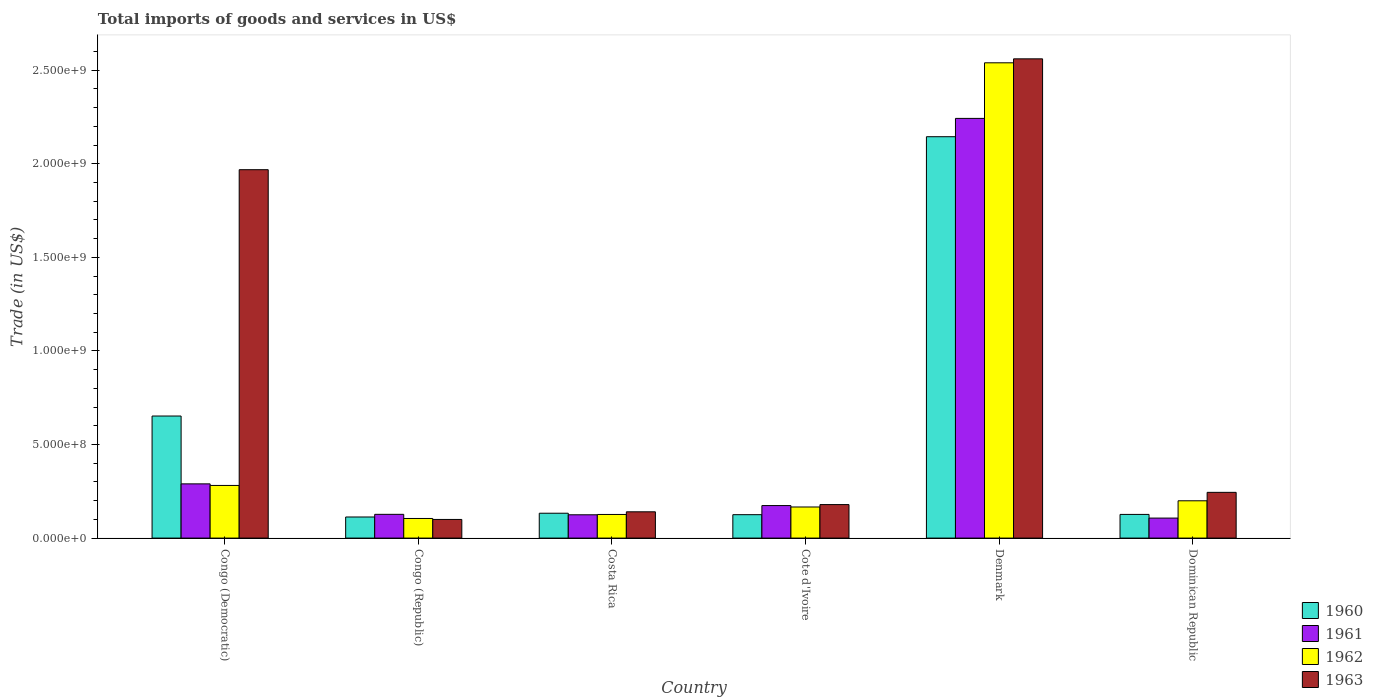Are the number of bars per tick equal to the number of legend labels?
Your answer should be very brief. Yes. Are the number of bars on each tick of the X-axis equal?
Provide a short and direct response. Yes. What is the label of the 2nd group of bars from the left?
Make the answer very short. Congo (Republic). What is the total imports of goods and services in 1963 in Dominican Republic?
Provide a succinct answer. 2.44e+08. Across all countries, what is the maximum total imports of goods and services in 1961?
Your answer should be very brief. 2.24e+09. Across all countries, what is the minimum total imports of goods and services in 1962?
Your answer should be very brief. 1.05e+08. In which country was the total imports of goods and services in 1961 maximum?
Offer a very short reply. Denmark. In which country was the total imports of goods and services in 1962 minimum?
Offer a terse response. Congo (Republic). What is the total total imports of goods and services in 1960 in the graph?
Your response must be concise. 3.29e+09. What is the difference between the total imports of goods and services in 1962 in Congo (Republic) and that in Cote d'Ivoire?
Your response must be concise. -6.13e+07. What is the difference between the total imports of goods and services in 1962 in Costa Rica and the total imports of goods and services in 1960 in Cote d'Ivoire?
Your response must be concise. 1.13e+06. What is the average total imports of goods and services in 1962 per country?
Give a very brief answer. 5.70e+08. What is the difference between the total imports of goods and services of/in 1962 and total imports of goods and services of/in 1961 in Congo (Republic)?
Offer a very short reply. -2.21e+07. In how many countries, is the total imports of goods and services in 1961 greater than 600000000 US$?
Ensure brevity in your answer.  1. What is the ratio of the total imports of goods and services in 1962 in Cote d'Ivoire to that in Denmark?
Your answer should be compact. 0.07. Is the total imports of goods and services in 1962 in Congo (Republic) less than that in Cote d'Ivoire?
Your answer should be very brief. Yes. What is the difference between the highest and the second highest total imports of goods and services in 1963?
Your answer should be compact. -1.72e+09. What is the difference between the highest and the lowest total imports of goods and services in 1960?
Give a very brief answer. 2.03e+09. In how many countries, is the total imports of goods and services in 1963 greater than the average total imports of goods and services in 1963 taken over all countries?
Your response must be concise. 2. Is it the case that in every country, the sum of the total imports of goods and services in 1960 and total imports of goods and services in 1961 is greater than the total imports of goods and services in 1962?
Your answer should be very brief. Yes. Are the values on the major ticks of Y-axis written in scientific E-notation?
Provide a short and direct response. Yes. Does the graph contain any zero values?
Keep it short and to the point. No. Where does the legend appear in the graph?
Give a very brief answer. Bottom right. How many legend labels are there?
Provide a short and direct response. 4. What is the title of the graph?
Provide a succinct answer. Total imports of goods and services in US$. Does "1969" appear as one of the legend labels in the graph?
Your response must be concise. No. What is the label or title of the Y-axis?
Give a very brief answer. Trade (in US$). What is the Trade (in US$) of 1960 in Congo (Democratic)?
Keep it short and to the point. 6.52e+08. What is the Trade (in US$) in 1961 in Congo (Democratic)?
Ensure brevity in your answer.  2.90e+08. What is the Trade (in US$) in 1962 in Congo (Democratic)?
Your answer should be compact. 2.81e+08. What is the Trade (in US$) in 1963 in Congo (Democratic)?
Offer a very short reply. 1.97e+09. What is the Trade (in US$) in 1960 in Congo (Republic)?
Make the answer very short. 1.13e+08. What is the Trade (in US$) in 1961 in Congo (Republic)?
Keep it short and to the point. 1.27e+08. What is the Trade (in US$) in 1962 in Congo (Republic)?
Provide a short and direct response. 1.05e+08. What is the Trade (in US$) in 1963 in Congo (Republic)?
Your answer should be very brief. 9.96e+07. What is the Trade (in US$) in 1960 in Costa Rica?
Make the answer very short. 1.33e+08. What is the Trade (in US$) of 1961 in Costa Rica?
Offer a terse response. 1.25e+08. What is the Trade (in US$) in 1962 in Costa Rica?
Your answer should be compact. 1.26e+08. What is the Trade (in US$) in 1963 in Costa Rica?
Your response must be concise. 1.40e+08. What is the Trade (in US$) of 1960 in Cote d'Ivoire?
Your answer should be very brief. 1.25e+08. What is the Trade (in US$) in 1961 in Cote d'Ivoire?
Offer a very short reply. 1.74e+08. What is the Trade (in US$) in 1962 in Cote d'Ivoire?
Your response must be concise. 1.66e+08. What is the Trade (in US$) of 1963 in Cote d'Ivoire?
Keep it short and to the point. 1.79e+08. What is the Trade (in US$) of 1960 in Denmark?
Provide a succinct answer. 2.14e+09. What is the Trade (in US$) in 1961 in Denmark?
Your answer should be very brief. 2.24e+09. What is the Trade (in US$) of 1962 in Denmark?
Keep it short and to the point. 2.54e+09. What is the Trade (in US$) of 1963 in Denmark?
Your answer should be very brief. 2.56e+09. What is the Trade (in US$) in 1960 in Dominican Republic?
Your answer should be very brief. 1.26e+08. What is the Trade (in US$) in 1961 in Dominican Republic?
Provide a short and direct response. 1.07e+08. What is the Trade (in US$) in 1962 in Dominican Republic?
Your answer should be very brief. 1.99e+08. What is the Trade (in US$) in 1963 in Dominican Republic?
Your answer should be compact. 2.44e+08. Across all countries, what is the maximum Trade (in US$) of 1960?
Your answer should be compact. 2.14e+09. Across all countries, what is the maximum Trade (in US$) of 1961?
Keep it short and to the point. 2.24e+09. Across all countries, what is the maximum Trade (in US$) of 1962?
Your response must be concise. 2.54e+09. Across all countries, what is the maximum Trade (in US$) in 1963?
Provide a succinct answer. 2.56e+09. Across all countries, what is the minimum Trade (in US$) of 1960?
Ensure brevity in your answer.  1.13e+08. Across all countries, what is the minimum Trade (in US$) of 1961?
Your answer should be compact. 1.07e+08. Across all countries, what is the minimum Trade (in US$) of 1962?
Make the answer very short. 1.05e+08. Across all countries, what is the minimum Trade (in US$) in 1963?
Offer a terse response. 9.96e+07. What is the total Trade (in US$) in 1960 in the graph?
Ensure brevity in your answer.  3.29e+09. What is the total Trade (in US$) in 1961 in the graph?
Provide a succinct answer. 3.06e+09. What is the total Trade (in US$) of 1962 in the graph?
Ensure brevity in your answer.  3.42e+09. What is the total Trade (in US$) of 1963 in the graph?
Make the answer very short. 5.19e+09. What is the difference between the Trade (in US$) in 1960 in Congo (Democratic) and that in Congo (Republic)?
Ensure brevity in your answer.  5.40e+08. What is the difference between the Trade (in US$) of 1961 in Congo (Democratic) and that in Congo (Republic)?
Give a very brief answer. 1.63e+08. What is the difference between the Trade (in US$) in 1962 in Congo (Democratic) and that in Congo (Republic)?
Keep it short and to the point. 1.76e+08. What is the difference between the Trade (in US$) in 1963 in Congo (Democratic) and that in Congo (Republic)?
Offer a terse response. 1.87e+09. What is the difference between the Trade (in US$) of 1960 in Congo (Democratic) and that in Costa Rica?
Offer a terse response. 5.19e+08. What is the difference between the Trade (in US$) in 1961 in Congo (Democratic) and that in Costa Rica?
Keep it short and to the point. 1.65e+08. What is the difference between the Trade (in US$) of 1962 in Congo (Democratic) and that in Costa Rica?
Give a very brief answer. 1.55e+08. What is the difference between the Trade (in US$) in 1963 in Congo (Democratic) and that in Costa Rica?
Your answer should be compact. 1.83e+09. What is the difference between the Trade (in US$) of 1960 in Congo (Democratic) and that in Cote d'Ivoire?
Keep it short and to the point. 5.27e+08. What is the difference between the Trade (in US$) in 1961 in Congo (Democratic) and that in Cote d'Ivoire?
Give a very brief answer. 1.16e+08. What is the difference between the Trade (in US$) of 1962 in Congo (Democratic) and that in Cote d'Ivoire?
Keep it short and to the point. 1.15e+08. What is the difference between the Trade (in US$) in 1963 in Congo (Democratic) and that in Cote d'Ivoire?
Keep it short and to the point. 1.79e+09. What is the difference between the Trade (in US$) of 1960 in Congo (Democratic) and that in Denmark?
Offer a very short reply. -1.49e+09. What is the difference between the Trade (in US$) of 1961 in Congo (Democratic) and that in Denmark?
Make the answer very short. -1.95e+09. What is the difference between the Trade (in US$) in 1962 in Congo (Democratic) and that in Denmark?
Make the answer very short. -2.26e+09. What is the difference between the Trade (in US$) of 1963 in Congo (Democratic) and that in Denmark?
Your answer should be very brief. -5.92e+08. What is the difference between the Trade (in US$) of 1960 in Congo (Democratic) and that in Dominican Republic?
Ensure brevity in your answer.  5.26e+08. What is the difference between the Trade (in US$) of 1961 in Congo (Democratic) and that in Dominican Republic?
Give a very brief answer. 1.83e+08. What is the difference between the Trade (in US$) of 1962 in Congo (Democratic) and that in Dominican Republic?
Give a very brief answer. 8.20e+07. What is the difference between the Trade (in US$) of 1963 in Congo (Democratic) and that in Dominican Republic?
Keep it short and to the point. 1.72e+09. What is the difference between the Trade (in US$) of 1960 in Congo (Republic) and that in Costa Rica?
Provide a short and direct response. -2.01e+07. What is the difference between the Trade (in US$) of 1961 in Congo (Republic) and that in Costa Rica?
Provide a succinct answer. 2.36e+06. What is the difference between the Trade (in US$) of 1962 in Congo (Republic) and that in Costa Rica?
Keep it short and to the point. -2.14e+07. What is the difference between the Trade (in US$) of 1963 in Congo (Republic) and that in Costa Rica?
Provide a succinct answer. -4.08e+07. What is the difference between the Trade (in US$) in 1960 in Congo (Republic) and that in Cote d'Ivoire?
Provide a succinct answer. -1.23e+07. What is the difference between the Trade (in US$) of 1961 in Congo (Republic) and that in Cote d'Ivoire?
Offer a terse response. -4.69e+07. What is the difference between the Trade (in US$) of 1962 in Congo (Republic) and that in Cote d'Ivoire?
Give a very brief answer. -6.13e+07. What is the difference between the Trade (in US$) in 1963 in Congo (Republic) and that in Cote d'Ivoire?
Offer a terse response. -7.94e+07. What is the difference between the Trade (in US$) in 1960 in Congo (Republic) and that in Denmark?
Your answer should be very brief. -2.03e+09. What is the difference between the Trade (in US$) in 1961 in Congo (Republic) and that in Denmark?
Your answer should be very brief. -2.12e+09. What is the difference between the Trade (in US$) in 1962 in Congo (Republic) and that in Denmark?
Your answer should be compact. -2.43e+09. What is the difference between the Trade (in US$) of 1963 in Congo (Republic) and that in Denmark?
Your response must be concise. -2.46e+09. What is the difference between the Trade (in US$) in 1960 in Congo (Republic) and that in Dominican Republic?
Your answer should be very brief. -1.37e+07. What is the difference between the Trade (in US$) in 1961 in Congo (Republic) and that in Dominican Republic?
Provide a short and direct response. 2.00e+07. What is the difference between the Trade (in US$) of 1962 in Congo (Republic) and that in Dominican Republic?
Provide a succinct answer. -9.45e+07. What is the difference between the Trade (in US$) in 1963 in Congo (Republic) and that in Dominican Republic?
Keep it short and to the point. -1.45e+08. What is the difference between the Trade (in US$) in 1960 in Costa Rica and that in Cote d'Ivoire?
Your answer should be very brief. 7.75e+06. What is the difference between the Trade (in US$) in 1961 in Costa Rica and that in Cote d'Ivoire?
Give a very brief answer. -4.92e+07. What is the difference between the Trade (in US$) of 1962 in Costa Rica and that in Cote d'Ivoire?
Provide a short and direct response. -3.99e+07. What is the difference between the Trade (in US$) in 1963 in Costa Rica and that in Cote d'Ivoire?
Provide a short and direct response. -3.86e+07. What is the difference between the Trade (in US$) in 1960 in Costa Rica and that in Denmark?
Your response must be concise. -2.01e+09. What is the difference between the Trade (in US$) in 1961 in Costa Rica and that in Denmark?
Your answer should be compact. -2.12e+09. What is the difference between the Trade (in US$) of 1962 in Costa Rica and that in Denmark?
Your response must be concise. -2.41e+09. What is the difference between the Trade (in US$) of 1963 in Costa Rica and that in Denmark?
Ensure brevity in your answer.  -2.42e+09. What is the difference between the Trade (in US$) of 1960 in Costa Rica and that in Dominican Republic?
Make the answer very short. 6.35e+06. What is the difference between the Trade (in US$) in 1961 in Costa Rica and that in Dominican Republic?
Give a very brief answer. 1.76e+07. What is the difference between the Trade (in US$) of 1962 in Costa Rica and that in Dominican Republic?
Make the answer very short. -7.31e+07. What is the difference between the Trade (in US$) in 1963 in Costa Rica and that in Dominican Republic?
Your answer should be very brief. -1.04e+08. What is the difference between the Trade (in US$) in 1960 in Cote d'Ivoire and that in Denmark?
Provide a succinct answer. -2.02e+09. What is the difference between the Trade (in US$) in 1961 in Cote d'Ivoire and that in Denmark?
Your answer should be very brief. -2.07e+09. What is the difference between the Trade (in US$) in 1962 in Cote d'Ivoire and that in Denmark?
Make the answer very short. -2.37e+09. What is the difference between the Trade (in US$) in 1963 in Cote d'Ivoire and that in Denmark?
Give a very brief answer. -2.38e+09. What is the difference between the Trade (in US$) of 1960 in Cote d'Ivoire and that in Dominican Republic?
Make the answer very short. -1.39e+06. What is the difference between the Trade (in US$) of 1961 in Cote d'Ivoire and that in Dominican Republic?
Provide a succinct answer. 6.68e+07. What is the difference between the Trade (in US$) of 1962 in Cote d'Ivoire and that in Dominican Republic?
Provide a short and direct response. -3.32e+07. What is the difference between the Trade (in US$) in 1963 in Cote d'Ivoire and that in Dominican Republic?
Offer a very short reply. -6.54e+07. What is the difference between the Trade (in US$) in 1960 in Denmark and that in Dominican Republic?
Keep it short and to the point. 2.02e+09. What is the difference between the Trade (in US$) in 1961 in Denmark and that in Dominican Republic?
Make the answer very short. 2.14e+09. What is the difference between the Trade (in US$) of 1962 in Denmark and that in Dominican Republic?
Give a very brief answer. 2.34e+09. What is the difference between the Trade (in US$) in 1963 in Denmark and that in Dominican Republic?
Keep it short and to the point. 2.32e+09. What is the difference between the Trade (in US$) of 1960 in Congo (Democratic) and the Trade (in US$) of 1961 in Congo (Republic)?
Provide a short and direct response. 5.25e+08. What is the difference between the Trade (in US$) of 1960 in Congo (Democratic) and the Trade (in US$) of 1962 in Congo (Republic)?
Offer a terse response. 5.47e+08. What is the difference between the Trade (in US$) of 1960 in Congo (Democratic) and the Trade (in US$) of 1963 in Congo (Republic)?
Ensure brevity in your answer.  5.53e+08. What is the difference between the Trade (in US$) of 1961 in Congo (Democratic) and the Trade (in US$) of 1962 in Congo (Republic)?
Your response must be concise. 1.85e+08. What is the difference between the Trade (in US$) of 1961 in Congo (Democratic) and the Trade (in US$) of 1963 in Congo (Republic)?
Make the answer very short. 1.90e+08. What is the difference between the Trade (in US$) of 1962 in Congo (Democratic) and the Trade (in US$) of 1963 in Congo (Republic)?
Make the answer very short. 1.82e+08. What is the difference between the Trade (in US$) of 1960 in Congo (Democratic) and the Trade (in US$) of 1961 in Costa Rica?
Your answer should be very brief. 5.28e+08. What is the difference between the Trade (in US$) of 1960 in Congo (Democratic) and the Trade (in US$) of 1962 in Costa Rica?
Offer a terse response. 5.26e+08. What is the difference between the Trade (in US$) in 1960 in Congo (Democratic) and the Trade (in US$) in 1963 in Costa Rica?
Provide a short and direct response. 5.12e+08. What is the difference between the Trade (in US$) in 1961 in Congo (Democratic) and the Trade (in US$) in 1962 in Costa Rica?
Keep it short and to the point. 1.64e+08. What is the difference between the Trade (in US$) in 1961 in Congo (Democratic) and the Trade (in US$) in 1963 in Costa Rica?
Offer a terse response. 1.49e+08. What is the difference between the Trade (in US$) in 1962 in Congo (Democratic) and the Trade (in US$) in 1963 in Costa Rica?
Your response must be concise. 1.41e+08. What is the difference between the Trade (in US$) in 1960 in Congo (Democratic) and the Trade (in US$) in 1961 in Cote d'Ivoire?
Your answer should be very brief. 4.79e+08. What is the difference between the Trade (in US$) in 1960 in Congo (Democratic) and the Trade (in US$) in 1962 in Cote d'Ivoire?
Give a very brief answer. 4.86e+08. What is the difference between the Trade (in US$) in 1960 in Congo (Democratic) and the Trade (in US$) in 1963 in Cote d'Ivoire?
Your response must be concise. 4.73e+08. What is the difference between the Trade (in US$) of 1961 in Congo (Democratic) and the Trade (in US$) of 1962 in Cote d'Ivoire?
Ensure brevity in your answer.  1.24e+08. What is the difference between the Trade (in US$) in 1961 in Congo (Democratic) and the Trade (in US$) in 1963 in Cote d'Ivoire?
Provide a succinct answer. 1.11e+08. What is the difference between the Trade (in US$) in 1962 in Congo (Democratic) and the Trade (in US$) in 1963 in Cote d'Ivoire?
Provide a short and direct response. 1.02e+08. What is the difference between the Trade (in US$) of 1960 in Congo (Democratic) and the Trade (in US$) of 1961 in Denmark?
Give a very brief answer. -1.59e+09. What is the difference between the Trade (in US$) in 1960 in Congo (Democratic) and the Trade (in US$) in 1962 in Denmark?
Make the answer very short. -1.89e+09. What is the difference between the Trade (in US$) of 1960 in Congo (Democratic) and the Trade (in US$) of 1963 in Denmark?
Ensure brevity in your answer.  -1.91e+09. What is the difference between the Trade (in US$) in 1961 in Congo (Democratic) and the Trade (in US$) in 1962 in Denmark?
Ensure brevity in your answer.  -2.25e+09. What is the difference between the Trade (in US$) in 1961 in Congo (Democratic) and the Trade (in US$) in 1963 in Denmark?
Keep it short and to the point. -2.27e+09. What is the difference between the Trade (in US$) of 1962 in Congo (Democratic) and the Trade (in US$) of 1963 in Denmark?
Offer a very short reply. -2.28e+09. What is the difference between the Trade (in US$) in 1960 in Congo (Democratic) and the Trade (in US$) in 1961 in Dominican Republic?
Provide a succinct answer. 5.45e+08. What is the difference between the Trade (in US$) in 1960 in Congo (Democratic) and the Trade (in US$) in 1962 in Dominican Republic?
Offer a terse response. 4.53e+08. What is the difference between the Trade (in US$) of 1960 in Congo (Democratic) and the Trade (in US$) of 1963 in Dominican Republic?
Give a very brief answer. 4.08e+08. What is the difference between the Trade (in US$) in 1961 in Congo (Democratic) and the Trade (in US$) in 1962 in Dominican Republic?
Make the answer very short. 9.05e+07. What is the difference between the Trade (in US$) in 1961 in Congo (Democratic) and the Trade (in US$) in 1963 in Dominican Republic?
Your answer should be compact. 4.54e+07. What is the difference between the Trade (in US$) in 1962 in Congo (Democratic) and the Trade (in US$) in 1963 in Dominican Republic?
Make the answer very short. 3.69e+07. What is the difference between the Trade (in US$) of 1960 in Congo (Republic) and the Trade (in US$) of 1961 in Costa Rica?
Make the answer very short. -1.18e+07. What is the difference between the Trade (in US$) in 1960 in Congo (Republic) and the Trade (in US$) in 1962 in Costa Rica?
Keep it short and to the point. -1.35e+07. What is the difference between the Trade (in US$) of 1960 in Congo (Republic) and the Trade (in US$) of 1963 in Costa Rica?
Your answer should be compact. -2.77e+07. What is the difference between the Trade (in US$) of 1961 in Congo (Republic) and the Trade (in US$) of 1962 in Costa Rica?
Provide a short and direct response. 6.55e+05. What is the difference between the Trade (in US$) of 1961 in Congo (Republic) and the Trade (in US$) of 1963 in Costa Rica?
Keep it short and to the point. -1.35e+07. What is the difference between the Trade (in US$) of 1962 in Congo (Republic) and the Trade (in US$) of 1963 in Costa Rica?
Provide a succinct answer. -3.56e+07. What is the difference between the Trade (in US$) in 1960 in Congo (Republic) and the Trade (in US$) in 1961 in Cote d'Ivoire?
Keep it short and to the point. -6.10e+07. What is the difference between the Trade (in US$) in 1960 in Congo (Republic) and the Trade (in US$) in 1962 in Cote d'Ivoire?
Make the answer very short. -5.34e+07. What is the difference between the Trade (in US$) of 1960 in Congo (Republic) and the Trade (in US$) of 1963 in Cote d'Ivoire?
Offer a very short reply. -6.62e+07. What is the difference between the Trade (in US$) in 1961 in Congo (Republic) and the Trade (in US$) in 1962 in Cote d'Ivoire?
Your response must be concise. -3.92e+07. What is the difference between the Trade (in US$) of 1961 in Congo (Republic) and the Trade (in US$) of 1963 in Cote d'Ivoire?
Your response must be concise. -5.21e+07. What is the difference between the Trade (in US$) in 1962 in Congo (Republic) and the Trade (in US$) in 1963 in Cote d'Ivoire?
Give a very brief answer. -7.42e+07. What is the difference between the Trade (in US$) in 1960 in Congo (Republic) and the Trade (in US$) in 1961 in Denmark?
Provide a succinct answer. -2.13e+09. What is the difference between the Trade (in US$) of 1960 in Congo (Republic) and the Trade (in US$) of 1962 in Denmark?
Keep it short and to the point. -2.43e+09. What is the difference between the Trade (in US$) of 1960 in Congo (Republic) and the Trade (in US$) of 1963 in Denmark?
Your answer should be very brief. -2.45e+09. What is the difference between the Trade (in US$) of 1961 in Congo (Republic) and the Trade (in US$) of 1962 in Denmark?
Your response must be concise. -2.41e+09. What is the difference between the Trade (in US$) in 1961 in Congo (Republic) and the Trade (in US$) in 1963 in Denmark?
Provide a short and direct response. -2.43e+09. What is the difference between the Trade (in US$) of 1962 in Congo (Republic) and the Trade (in US$) of 1963 in Denmark?
Your answer should be very brief. -2.46e+09. What is the difference between the Trade (in US$) in 1960 in Congo (Republic) and the Trade (in US$) in 1961 in Dominican Republic?
Provide a succinct answer. 5.87e+06. What is the difference between the Trade (in US$) in 1960 in Congo (Republic) and the Trade (in US$) in 1962 in Dominican Republic?
Your response must be concise. -8.65e+07. What is the difference between the Trade (in US$) in 1960 in Congo (Republic) and the Trade (in US$) in 1963 in Dominican Republic?
Offer a terse response. -1.32e+08. What is the difference between the Trade (in US$) of 1961 in Congo (Republic) and the Trade (in US$) of 1962 in Dominican Republic?
Provide a succinct answer. -7.24e+07. What is the difference between the Trade (in US$) in 1961 in Congo (Republic) and the Trade (in US$) in 1963 in Dominican Republic?
Keep it short and to the point. -1.18e+08. What is the difference between the Trade (in US$) of 1962 in Congo (Republic) and the Trade (in US$) of 1963 in Dominican Republic?
Provide a short and direct response. -1.40e+08. What is the difference between the Trade (in US$) in 1960 in Costa Rica and the Trade (in US$) in 1961 in Cote d'Ivoire?
Give a very brief answer. -4.09e+07. What is the difference between the Trade (in US$) in 1960 in Costa Rica and the Trade (in US$) in 1962 in Cote d'Ivoire?
Offer a very short reply. -3.33e+07. What is the difference between the Trade (in US$) in 1960 in Costa Rica and the Trade (in US$) in 1963 in Cote d'Ivoire?
Ensure brevity in your answer.  -4.61e+07. What is the difference between the Trade (in US$) in 1961 in Costa Rica and the Trade (in US$) in 1962 in Cote d'Ivoire?
Keep it short and to the point. -4.16e+07. What is the difference between the Trade (in US$) in 1961 in Costa Rica and the Trade (in US$) in 1963 in Cote d'Ivoire?
Give a very brief answer. -5.45e+07. What is the difference between the Trade (in US$) in 1962 in Costa Rica and the Trade (in US$) in 1963 in Cote d'Ivoire?
Offer a very short reply. -5.28e+07. What is the difference between the Trade (in US$) in 1960 in Costa Rica and the Trade (in US$) in 1961 in Denmark?
Provide a short and direct response. -2.11e+09. What is the difference between the Trade (in US$) of 1960 in Costa Rica and the Trade (in US$) of 1962 in Denmark?
Provide a short and direct response. -2.41e+09. What is the difference between the Trade (in US$) in 1960 in Costa Rica and the Trade (in US$) in 1963 in Denmark?
Offer a very short reply. -2.43e+09. What is the difference between the Trade (in US$) of 1961 in Costa Rica and the Trade (in US$) of 1962 in Denmark?
Provide a succinct answer. -2.42e+09. What is the difference between the Trade (in US$) of 1961 in Costa Rica and the Trade (in US$) of 1963 in Denmark?
Your answer should be compact. -2.44e+09. What is the difference between the Trade (in US$) in 1962 in Costa Rica and the Trade (in US$) in 1963 in Denmark?
Offer a very short reply. -2.43e+09. What is the difference between the Trade (in US$) in 1960 in Costa Rica and the Trade (in US$) in 1961 in Dominican Republic?
Keep it short and to the point. 2.60e+07. What is the difference between the Trade (in US$) of 1960 in Costa Rica and the Trade (in US$) of 1962 in Dominican Republic?
Your answer should be very brief. -6.64e+07. What is the difference between the Trade (in US$) in 1960 in Costa Rica and the Trade (in US$) in 1963 in Dominican Republic?
Ensure brevity in your answer.  -1.12e+08. What is the difference between the Trade (in US$) of 1961 in Costa Rica and the Trade (in US$) of 1962 in Dominican Republic?
Provide a short and direct response. -7.48e+07. What is the difference between the Trade (in US$) in 1961 in Costa Rica and the Trade (in US$) in 1963 in Dominican Republic?
Ensure brevity in your answer.  -1.20e+08. What is the difference between the Trade (in US$) of 1962 in Costa Rica and the Trade (in US$) of 1963 in Dominican Republic?
Ensure brevity in your answer.  -1.18e+08. What is the difference between the Trade (in US$) of 1960 in Cote d'Ivoire and the Trade (in US$) of 1961 in Denmark?
Your answer should be compact. -2.12e+09. What is the difference between the Trade (in US$) in 1960 in Cote d'Ivoire and the Trade (in US$) in 1962 in Denmark?
Make the answer very short. -2.41e+09. What is the difference between the Trade (in US$) in 1960 in Cote d'Ivoire and the Trade (in US$) in 1963 in Denmark?
Provide a short and direct response. -2.44e+09. What is the difference between the Trade (in US$) of 1961 in Cote d'Ivoire and the Trade (in US$) of 1962 in Denmark?
Your answer should be very brief. -2.37e+09. What is the difference between the Trade (in US$) of 1961 in Cote d'Ivoire and the Trade (in US$) of 1963 in Denmark?
Provide a short and direct response. -2.39e+09. What is the difference between the Trade (in US$) of 1962 in Cote d'Ivoire and the Trade (in US$) of 1963 in Denmark?
Make the answer very short. -2.39e+09. What is the difference between the Trade (in US$) in 1960 in Cote d'Ivoire and the Trade (in US$) in 1961 in Dominican Republic?
Ensure brevity in your answer.  1.82e+07. What is the difference between the Trade (in US$) in 1960 in Cote d'Ivoire and the Trade (in US$) in 1962 in Dominican Republic?
Give a very brief answer. -7.42e+07. What is the difference between the Trade (in US$) in 1960 in Cote d'Ivoire and the Trade (in US$) in 1963 in Dominican Republic?
Offer a very short reply. -1.19e+08. What is the difference between the Trade (in US$) in 1961 in Cote d'Ivoire and the Trade (in US$) in 1962 in Dominican Republic?
Your response must be concise. -2.56e+07. What is the difference between the Trade (in US$) of 1961 in Cote d'Ivoire and the Trade (in US$) of 1963 in Dominican Republic?
Your answer should be compact. -7.07e+07. What is the difference between the Trade (in US$) of 1962 in Cote d'Ivoire and the Trade (in US$) of 1963 in Dominican Republic?
Offer a very short reply. -7.83e+07. What is the difference between the Trade (in US$) in 1960 in Denmark and the Trade (in US$) in 1961 in Dominican Republic?
Offer a very short reply. 2.04e+09. What is the difference between the Trade (in US$) of 1960 in Denmark and the Trade (in US$) of 1962 in Dominican Republic?
Provide a short and direct response. 1.95e+09. What is the difference between the Trade (in US$) in 1960 in Denmark and the Trade (in US$) in 1963 in Dominican Republic?
Offer a terse response. 1.90e+09. What is the difference between the Trade (in US$) in 1961 in Denmark and the Trade (in US$) in 1962 in Dominican Republic?
Ensure brevity in your answer.  2.04e+09. What is the difference between the Trade (in US$) in 1961 in Denmark and the Trade (in US$) in 1963 in Dominican Republic?
Offer a terse response. 2.00e+09. What is the difference between the Trade (in US$) of 1962 in Denmark and the Trade (in US$) of 1963 in Dominican Republic?
Ensure brevity in your answer.  2.30e+09. What is the average Trade (in US$) of 1960 per country?
Your answer should be compact. 5.49e+08. What is the average Trade (in US$) of 1961 per country?
Keep it short and to the point. 5.11e+08. What is the average Trade (in US$) of 1962 per country?
Offer a very short reply. 5.70e+08. What is the average Trade (in US$) in 1963 per country?
Offer a terse response. 8.65e+08. What is the difference between the Trade (in US$) in 1960 and Trade (in US$) in 1961 in Congo (Democratic)?
Your answer should be compact. 3.63e+08. What is the difference between the Trade (in US$) of 1960 and Trade (in US$) of 1962 in Congo (Democratic)?
Your response must be concise. 3.71e+08. What is the difference between the Trade (in US$) in 1960 and Trade (in US$) in 1963 in Congo (Democratic)?
Give a very brief answer. -1.32e+09. What is the difference between the Trade (in US$) in 1961 and Trade (in US$) in 1962 in Congo (Democratic)?
Provide a succinct answer. 8.49e+06. What is the difference between the Trade (in US$) of 1961 and Trade (in US$) of 1963 in Congo (Democratic)?
Ensure brevity in your answer.  -1.68e+09. What is the difference between the Trade (in US$) in 1962 and Trade (in US$) in 1963 in Congo (Democratic)?
Keep it short and to the point. -1.69e+09. What is the difference between the Trade (in US$) of 1960 and Trade (in US$) of 1961 in Congo (Republic)?
Give a very brief answer. -1.41e+07. What is the difference between the Trade (in US$) of 1960 and Trade (in US$) of 1962 in Congo (Republic)?
Offer a terse response. 7.94e+06. What is the difference between the Trade (in US$) of 1960 and Trade (in US$) of 1963 in Congo (Republic)?
Your answer should be very brief. 1.31e+07. What is the difference between the Trade (in US$) of 1961 and Trade (in US$) of 1962 in Congo (Republic)?
Offer a very short reply. 2.21e+07. What is the difference between the Trade (in US$) in 1961 and Trade (in US$) in 1963 in Congo (Republic)?
Offer a very short reply. 2.73e+07. What is the difference between the Trade (in US$) in 1962 and Trade (in US$) in 1963 in Congo (Republic)?
Give a very brief answer. 5.20e+06. What is the difference between the Trade (in US$) in 1960 and Trade (in US$) in 1961 in Costa Rica?
Your answer should be compact. 8.32e+06. What is the difference between the Trade (in US$) in 1960 and Trade (in US$) in 1962 in Costa Rica?
Your response must be concise. 6.62e+06. What is the difference between the Trade (in US$) of 1960 and Trade (in US$) of 1963 in Costa Rica?
Offer a terse response. -7.58e+06. What is the difference between the Trade (in US$) in 1961 and Trade (in US$) in 1962 in Costa Rica?
Offer a terse response. -1.70e+06. What is the difference between the Trade (in US$) of 1961 and Trade (in US$) of 1963 in Costa Rica?
Ensure brevity in your answer.  -1.59e+07. What is the difference between the Trade (in US$) in 1962 and Trade (in US$) in 1963 in Costa Rica?
Give a very brief answer. -1.42e+07. What is the difference between the Trade (in US$) of 1960 and Trade (in US$) of 1961 in Cote d'Ivoire?
Make the answer very short. -4.86e+07. What is the difference between the Trade (in US$) of 1960 and Trade (in US$) of 1962 in Cote d'Ivoire?
Your answer should be very brief. -4.10e+07. What is the difference between the Trade (in US$) of 1960 and Trade (in US$) of 1963 in Cote d'Ivoire?
Make the answer very short. -5.39e+07. What is the difference between the Trade (in US$) in 1961 and Trade (in US$) in 1962 in Cote d'Ivoire?
Offer a very short reply. 7.61e+06. What is the difference between the Trade (in US$) in 1961 and Trade (in US$) in 1963 in Cote d'Ivoire?
Make the answer very short. -5.25e+06. What is the difference between the Trade (in US$) of 1962 and Trade (in US$) of 1963 in Cote d'Ivoire?
Keep it short and to the point. -1.29e+07. What is the difference between the Trade (in US$) of 1960 and Trade (in US$) of 1961 in Denmark?
Offer a very short reply. -9.78e+07. What is the difference between the Trade (in US$) of 1960 and Trade (in US$) of 1962 in Denmark?
Keep it short and to the point. -3.95e+08. What is the difference between the Trade (in US$) in 1960 and Trade (in US$) in 1963 in Denmark?
Your answer should be very brief. -4.16e+08. What is the difference between the Trade (in US$) in 1961 and Trade (in US$) in 1962 in Denmark?
Give a very brief answer. -2.97e+08. What is the difference between the Trade (in US$) of 1961 and Trade (in US$) of 1963 in Denmark?
Offer a terse response. -3.18e+08. What is the difference between the Trade (in US$) in 1962 and Trade (in US$) in 1963 in Denmark?
Provide a succinct answer. -2.12e+07. What is the difference between the Trade (in US$) of 1960 and Trade (in US$) of 1961 in Dominican Republic?
Make the answer very short. 1.96e+07. What is the difference between the Trade (in US$) of 1960 and Trade (in US$) of 1962 in Dominican Republic?
Offer a very short reply. -7.28e+07. What is the difference between the Trade (in US$) of 1960 and Trade (in US$) of 1963 in Dominican Republic?
Make the answer very short. -1.18e+08. What is the difference between the Trade (in US$) of 1961 and Trade (in US$) of 1962 in Dominican Republic?
Keep it short and to the point. -9.24e+07. What is the difference between the Trade (in US$) in 1961 and Trade (in US$) in 1963 in Dominican Republic?
Offer a terse response. -1.38e+08. What is the difference between the Trade (in US$) in 1962 and Trade (in US$) in 1963 in Dominican Republic?
Offer a very short reply. -4.51e+07. What is the ratio of the Trade (in US$) of 1960 in Congo (Democratic) to that in Congo (Republic)?
Your response must be concise. 5.78. What is the ratio of the Trade (in US$) of 1961 in Congo (Democratic) to that in Congo (Republic)?
Provide a succinct answer. 2.28. What is the ratio of the Trade (in US$) in 1962 in Congo (Democratic) to that in Congo (Republic)?
Ensure brevity in your answer.  2.68. What is the ratio of the Trade (in US$) in 1963 in Congo (Democratic) to that in Congo (Republic)?
Keep it short and to the point. 19.76. What is the ratio of the Trade (in US$) of 1960 in Congo (Democratic) to that in Costa Rica?
Your answer should be very brief. 4.91. What is the ratio of the Trade (in US$) of 1961 in Congo (Democratic) to that in Costa Rica?
Offer a terse response. 2.33. What is the ratio of the Trade (in US$) of 1962 in Congo (Democratic) to that in Costa Rica?
Provide a succinct answer. 2.23. What is the ratio of the Trade (in US$) of 1963 in Congo (Democratic) to that in Costa Rica?
Ensure brevity in your answer.  14.02. What is the ratio of the Trade (in US$) in 1960 in Congo (Democratic) to that in Cote d'Ivoire?
Offer a terse response. 5.21. What is the ratio of the Trade (in US$) of 1961 in Congo (Democratic) to that in Cote d'Ivoire?
Make the answer very short. 1.67. What is the ratio of the Trade (in US$) in 1962 in Congo (Democratic) to that in Cote d'Ivoire?
Keep it short and to the point. 1.69. What is the ratio of the Trade (in US$) in 1963 in Congo (Democratic) to that in Cote d'Ivoire?
Provide a short and direct response. 11. What is the ratio of the Trade (in US$) in 1960 in Congo (Democratic) to that in Denmark?
Offer a very short reply. 0.3. What is the ratio of the Trade (in US$) in 1961 in Congo (Democratic) to that in Denmark?
Make the answer very short. 0.13. What is the ratio of the Trade (in US$) of 1962 in Congo (Democratic) to that in Denmark?
Your response must be concise. 0.11. What is the ratio of the Trade (in US$) of 1963 in Congo (Democratic) to that in Denmark?
Your answer should be compact. 0.77. What is the ratio of the Trade (in US$) in 1960 in Congo (Democratic) to that in Dominican Republic?
Offer a very short reply. 5.16. What is the ratio of the Trade (in US$) in 1961 in Congo (Democratic) to that in Dominican Republic?
Provide a short and direct response. 2.71. What is the ratio of the Trade (in US$) of 1962 in Congo (Democratic) to that in Dominican Republic?
Give a very brief answer. 1.41. What is the ratio of the Trade (in US$) in 1963 in Congo (Democratic) to that in Dominican Republic?
Give a very brief answer. 8.05. What is the ratio of the Trade (in US$) in 1960 in Congo (Republic) to that in Costa Rica?
Your answer should be very brief. 0.85. What is the ratio of the Trade (in US$) of 1961 in Congo (Republic) to that in Costa Rica?
Keep it short and to the point. 1.02. What is the ratio of the Trade (in US$) of 1962 in Congo (Republic) to that in Costa Rica?
Your answer should be very brief. 0.83. What is the ratio of the Trade (in US$) in 1963 in Congo (Republic) to that in Costa Rica?
Offer a terse response. 0.71. What is the ratio of the Trade (in US$) of 1960 in Congo (Republic) to that in Cote d'Ivoire?
Provide a short and direct response. 0.9. What is the ratio of the Trade (in US$) in 1961 in Congo (Republic) to that in Cote d'Ivoire?
Provide a short and direct response. 0.73. What is the ratio of the Trade (in US$) of 1962 in Congo (Republic) to that in Cote d'Ivoire?
Provide a succinct answer. 0.63. What is the ratio of the Trade (in US$) of 1963 in Congo (Republic) to that in Cote d'Ivoire?
Your response must be concise. 0.56. What is the ratio of the Trade (in US$) of 1960 in Congo (Republic) to that in Denmark?
Provide a short and direct response. 0.05. What is the ratio of the Trade (in US$) in 1961 in Congo (Republic) to that in Denmark?
Provide a short and direct response. 0.06. What is the ratio of the Trade (in US$) of 1962 in Congo (Republic) to that in Denmark?
Make the answer very short. 0.04. What is the ratio of the Trade (in US$) in 1963 in Congo (Republic) to that in Denmark?
Give a very brief answer. 0.04. What is the ratio of the Trade (in US$) in 1960 in Congo (Republic) to that in Dominican Republic?
Offer a terse response. 0.89. What is the ratio of the Trade (in US$) of 1961 in Congo (Republic) to that in Dominican Republic?
Give a very brief answer. 1.19. What is the ratio of the Trade (in US$) of 1962 in Congo (Republic) to that in Dominican Republic?
Keep it short and to the point. 0.53. What is the ratio of the Trade (in US$) of 1963 in Congo (Republic) to that in Dominican Republic?
Give a very brief answer. 0.41. What is the ratio of the Trade (in US$) of 1960 in Costa Rica to that in Cote d'Ivoire?
Offer a very short reply. 1.06. What is the ratio of the Trade (in US$) of 1961 in Costa Rica to that in Cote d'Ivoire?
Keep it short and to the point. 0.72. What is the ratio of the Trade (in US$) of 1962 in Costa Rica to that in Cote d'Ivoire?
Your answer should be very brief. 0.76. What is the ratio of the Trade (in US$) in 1963 in Costa Rica to that in Cote d'Ivoire?
Your answer should be very brief. 0.78. What is the ratio of the Trade (in US$) in 1960 in Costa Rica to that in Denmark?
Your answer should be compact. 0.06. What is the ratio of the Trade (in US$) in 1961 in Costa Rica to that in Denmark?
Offer a terse response. 0.06. What is the ratio of the Trade (in US$) of 1962 in Costa Rica to that in Denmark?
Your response must be concise. 0.05. What is the ratio of the Trade (in US$) in 1963 in Costa Rica to that in Denmark?
Your response must be concise. 0.05. What is the ratio of the Trade (in US$) of 1960 in Costa Rica to that in Dominican Republic?
Your answer should be compact. 1.05. What is the ratio of the Trade (in US$) in 1961 in Costa Rica to that in Dominican Republic?
Your answer should be compact. 1.17. What is the ratio of the Trade (in US$) in 1962 in Costa Rica to that in Dominican Republic?
Your response must be concise. 0.63. What is the ratio of the Trade (in US$) of 1963 in Costa Rica to that in Dominican Republic?
Provide a succinct answer. 0.57. What is the ratio of the Trade (in US$) in 1960 in Cote d'Ivoire to that in Denmark?
Provide a short and direct response. 0.06. What is the ratio of the Trade (in US$) of 1961 in Cote d'Ivoire to that in Denmark?
Ensure brevity in your answer.  0.08. What is the ratio of the Trade (in US$) of 1962 in Cote d'Ivoire to that in Denmark?
Ensure brevity in your answer.  0.07. What is the ratio of the Trade (in US$) in 1963 in Cote d'Ivoire to that in Denmark?
Ensure brevity in your answer.  0.07. What is the ratio of the Trade (in US$) of 1961 in Cote d'Ivoire to that in Dominican Republic?
Your response must be concise. 1.63. What is the ratio of the Trade (in US$) in 1962 in Cote d'Ivoire to that in Dominican Republic?
Keep it short and to the point. 0.83. What is the ratio of the Trade (in US$) in 1963 in Cote d'Ivoire to that in Dominican Republic?
Keep it short and to the point. 0.73. What is the ratio of the Trade (in US$) in 1960 in Denmark to that in Dominican Republic?
Keep it short and to the point. 16.95. What is the ratio of the Trade (in US$) in 1961 in Denmark to that in Dominican Republic?
Give a very brief answer. 20.98. What is the ratio of the Trade (in US$) in 1962 in Denmark to that in Dominican Republic?
Provide a succinct answer. 12.74. What is the ratio of the Trade (in US$) in 1963 in Denmark to that in Dominican Republic?
Offer a terse response. 10.48. What is the difference between the highest and the second highest Trade (in US$) in 1960?
Your answer should be very brief. 1.49e+09. What is the difference between the highest and the second highest Trade (in US$) in 1961?
Give a very brief answer. 1.95e+09. What is the difference between the highest and the second highest Trade (in US$) in 1962?
Your response must be concise. 2.26e+09. What is the difference between the highest and the second highest Trade (in US$) of 1963?
Your response must be concise. 5.92e+08. What is the difference between the highest and the lowest Trade (in US$) in 1960?
Ensure brevity in your answer.  2.03e+09. What is the difference between the highest and the lowest Trade (in US$) in 1961?
Ensure brevity in your answer.  2.14e+09. What is the difference between the highest and the lowest Trade (in US$) in 1962?
Ensure brevity in your answer.  2.43e+09. What is the difference between the highest and the lowest Trade (in US$) of 1963?
Offer a terse response. 2.46e+09. 